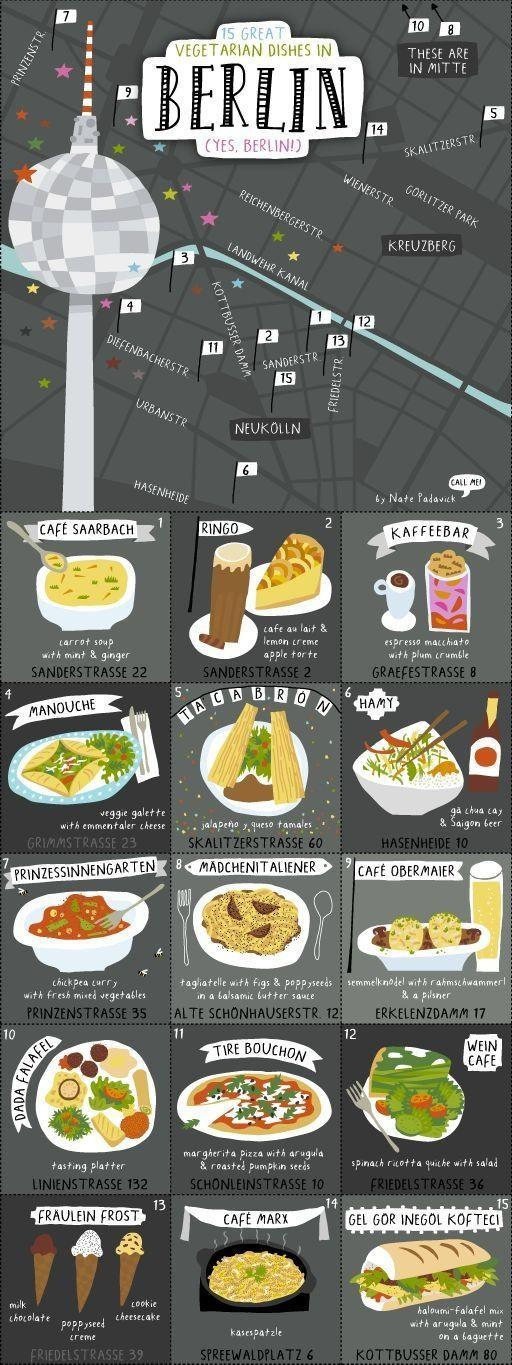What is the vegetarian dish served at Wein Cafe located at Friedelstrasse 36?
Answer the question with a short phrase. spinach ricotta quiche with salad Where is Cafe Saarbach located? Sanderstrasse 22 Which are the eateries that serve vegetarian dishes in Prinzenstrasse? Prinzessinnengarten Which are the eateries that serve vegetarian dishes in Hasenheide? Hamy Which eateries are in Mitte? Dada Falafel,Madchenitaliener Which are the eateries that serve vegetarian dishes in Grimmstrasse? Manouche Which are the eateries that serve vegetarian dishes in Friedelstrasse? Wein Cafe,Fraulein Frost Which eatery serves carrot soup with mint and ginger? Cafe Saarbach What is the vegetarian dish served in Cafe Mark that is listed in the infographic? kasespatzle Which is the eatery that serves vegetarian dishes in Sanderstrasse 2? Ringo 